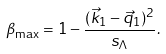<formula> <loc_0><loc_0><loc_500><loc_500>\beta _ { \max } = 1 - \frac { ( \vec { k } _ { 1 } - \vec { q } _ { 1 } ) ^ { 2 } } { s _ { \Lambda } } .</formula> 